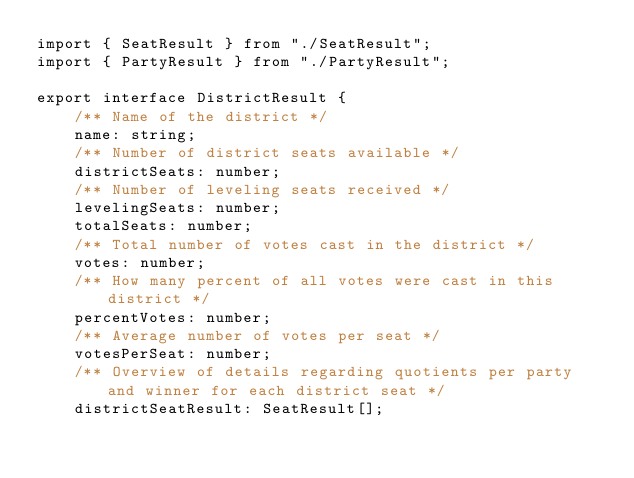<code> <loc_0><loc_0><loc_500><loc_500><_TypeScript_>import { SeatResult } from "./SeatResult";
import { PartyResult } from "./PartyResult";

export interface DistrictResult {
    /** Name of the district */
    name: string;
    /** Number of district seats available */
    districtSeats: number;
    /** Number of leveling seats received */
    levelingSeats: number;
    totalSeats: number;
    /** Total number of votes cast in the district */
    votes: number;
    /** How many percent of all votes were cast in this district */
    percentVotes: number;
    /** Average number of votes per seat */
    votesPerSeat: number;
    /** Overview of details regarding quotients per party and winner for each district seat */
    districtSeatResult: SeatResult[];</code> 